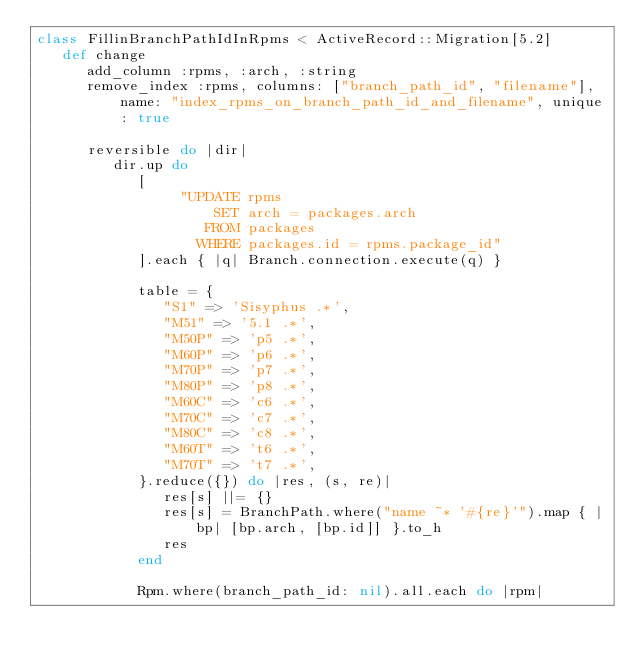<code> <loc_0><loc_0><loc_500><loc_500><_Ruby_>class FillinBranchPathIdInRpms < ActiveRecord::Migration[5.2]
   def change
      add_column :rpms, :arch, :string
      remove_index :rpms, columns: ["branch_path_id", "filename"], name: "index_rpms_on_branch_path_id_and_filename", unique: true

      reversible do |dir|
         dir.up do
            [
                 "UPDATE rpms
                     SET arch = packages.arch
                    FROM packages
                   WHERE packages.id = rpms.package_id"
            ].each { |q| Branch.connection.execute(q) }

            table = {
               "S1" => 'Sisyphus .*',
               "M51" => '5.1 .*',
               "M50P" => 'p5 .*',
               "M60P" => 'p6 .*',
               "M70P" => 'p7 .*',
               "M80P" => 'p8 .*',
               "M60C" => 'c6 .*',
               "M70C" => 'c7 .*',
               "M80C" => 'c8 .*',
               "M60T" => 't6 .*',
               "M70T" => 't7 .*',
            }.reduce({}) do |res, (s, re)|
               res[s] ||= {}
               res[s] = BranchPath.where("name ~* '#{re}'").map { |bp| [bp.arch, [bp.id]] }.to_h
               res
            end

            Rpm.where(branch_path_id: nil).all.each do |rpm|</code> 